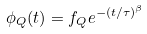<formula> <loc_0><loc_0><loc_500><loc_500>\phi _ { Q } ( t ) = f _ { Q } e ^ { - ( t / \tau ) ^ { \beta } }</formula> 